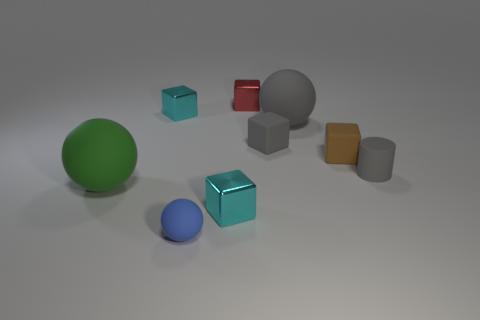There is a small shiny object that is to the left of the small cyan metallic thing that is in front of the ball that is left of the blue sphere; what color is it?
Give a very brief answer. Cyan. What number of tiny rubber blocks are there?
Keep it short and to the point. 2. What number of big things are brown cylinders or red metal objects?
Offer a very short reply. 0. There is a brown matte object that is the same size as the red shiny block; what is its shape?
Give a very brief answer. Cube. There is a big thing that is on the left side of the cyan metal cube in front of the small gray cylinder; what is its material?
Provide a succinct answer. Rubber. Do the green sphere and the blue thing have the same size?
Your answer should be compact. No. How many things are small cyan shiny objects in front of the small gray rubber cube or small green balls?
Your answer should be very brief. 1. There is a metal thing that is in front of the small gray object behind the gray cylinder; what shape is it?
Give a very brief answer. Cube. There is a blue rubber object; does it have the same size as the green thing on the left side of the big gray thing?
Give a very brief answer. No. What is the tiny cyan cube that is behind the small gray block made of?
Make the answer very short. Metal. 